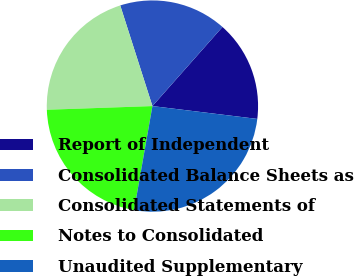<chart> <loc_0><loc_0><loc_500><loc_500><pie_chart><fcel>Report of Independent<fcel>Consolidated Balance Sheets as<fcel>Consolidated Statements of<fcel>Notes to Consolidated<fcel>Unaudited Supplementary<nl><fcel>15.41%<fcel>16.46%<fcel>20.63%<fcel>21.67%<fcel>25.84%<nl></chart> 